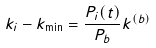Convert formula to latex. <formula><loc_0><loc_0><loc_500><loc_500>k _ { i } - k _ { \min } = \frac { P _ { i } ( t ) } { P _ { b } } k ^ { ( b ) }</formula> 